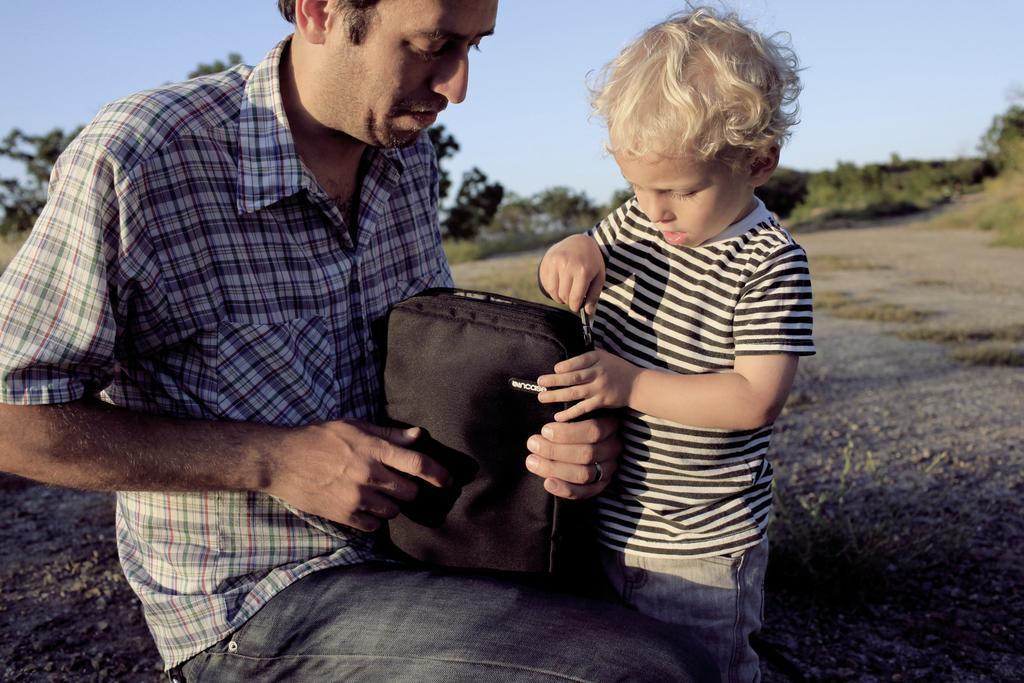Can you describe this image briefly? In this picture we can observe a man sitting. In front of him there is a kid holding a bag zip which is in black color. We can observe some trees in the background. There is a sky. 